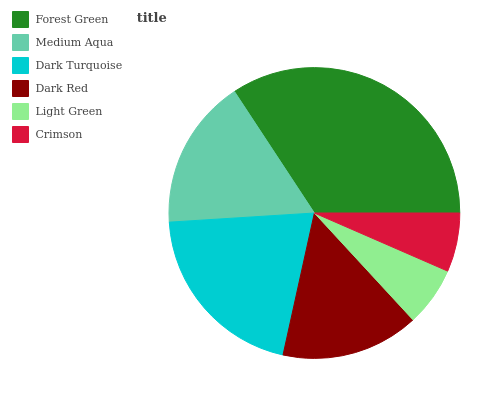Is Crimson the minimum?
Answer yes or no. Yes. Is Forest Green the maximum?
Answer yes or no. Yes. Is Medium Aqua the minimum?
Answer yes or no. No. Is Medium Aqua the maximum?
Answer yes or no. No. Is Forest Green greater than Medium Aqua?
Answer yes or no. Yes. Is Medium Aqua less than Forest Green?
Answer yes or no. Yes. Is Medium Aqua greater than Forest Green?
Answer yes or no. No. Is Forest Green less than Medium Aqua?
Answer yes or no. No. Is Medium Aqua the high median?
Answer yes or no. Yes. Is Dark Red the low median?
Answer yes or no. Yes. Is Light Green the high median?
Answer yes or no. No. Is Forest Green the low median?
Answer yes or no. No. 